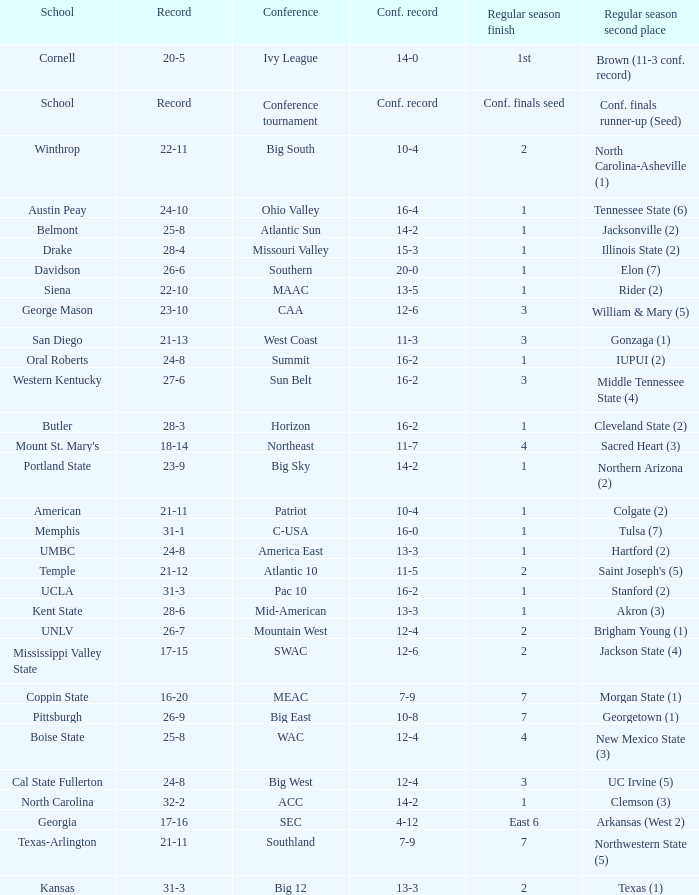For squads in the sun belt conference, what is the conference record? 16-2. 